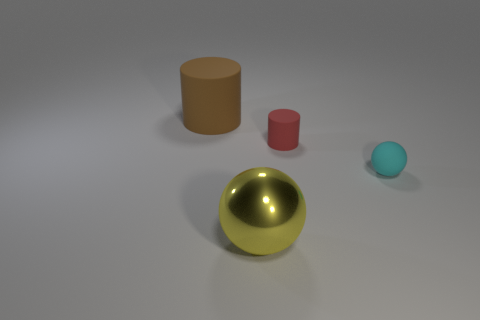Are there any other large brown rubber things that have the same shape as the big brown thing?
Your response must be concise. No. Do the matte cylinder that is left of the yellow shiny ball and the cyan sphere have the same size?
Ensure brevity in your answer.  No. How big is the object that is to the left of the red thing and right of the large matte thing?
Keep it short and to the point. Large. How many other objects are the same material as the small cyan ball?
Give a very brief answer. 2. There is a yellow shiny object that is left of the small cylinder; how big is it?
Your answer should be very brief. Large. How many small things are matte cylinders or brown matte objects?
Your answer should be compact. 1. There is a small red rubber object; are there any red cylinders on the left side of it?
Provide a short and direct response. No. There is a thing that is on the left side of the big thing on the right side of the big brown matte object; what size is it?
Keep it short and to the point. Large. Are there the same number of rubber objects that are to the right of the tiny cylinder and small cyan rubber objects that are in front of the yellow ball?
Keep it short and to the point. No. There is a yellow sphere right of the large brown rubber thing; is there a thing that is to the left of it?
Provide a succinct answer. Yes. 